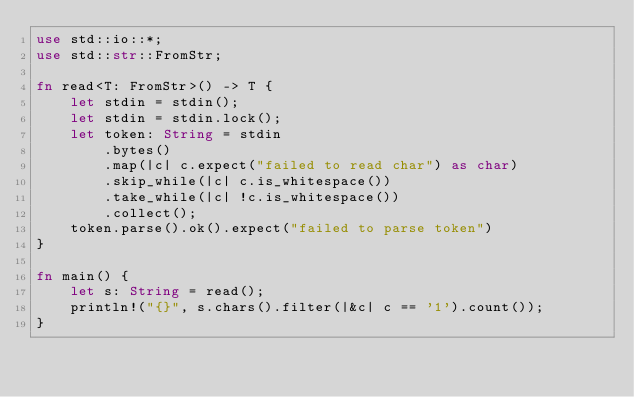<code> <loc_0><loc_0><loc_500><loc_500><_Rust_>use std::io::*;
use std::str::FromStr;

fn read<T: FromStr>() -> T {
    let stdin = stdin();
    let stdin = stdin.lock();
    let token: String = stdin
        .bytes()
        .map(|c| c.expect("failed to read char") as char)
        .skip_while(|c| c.is_whitespace())
        .take_while(|c| !c.is_whitespace())
        .collect();
    token.parse().ok().expect("failed to parse token")
}

fn main() {
    let s: String = read();
    println!("{}", s.chars().filter(|&c| c == '1').count());
}
</code> 